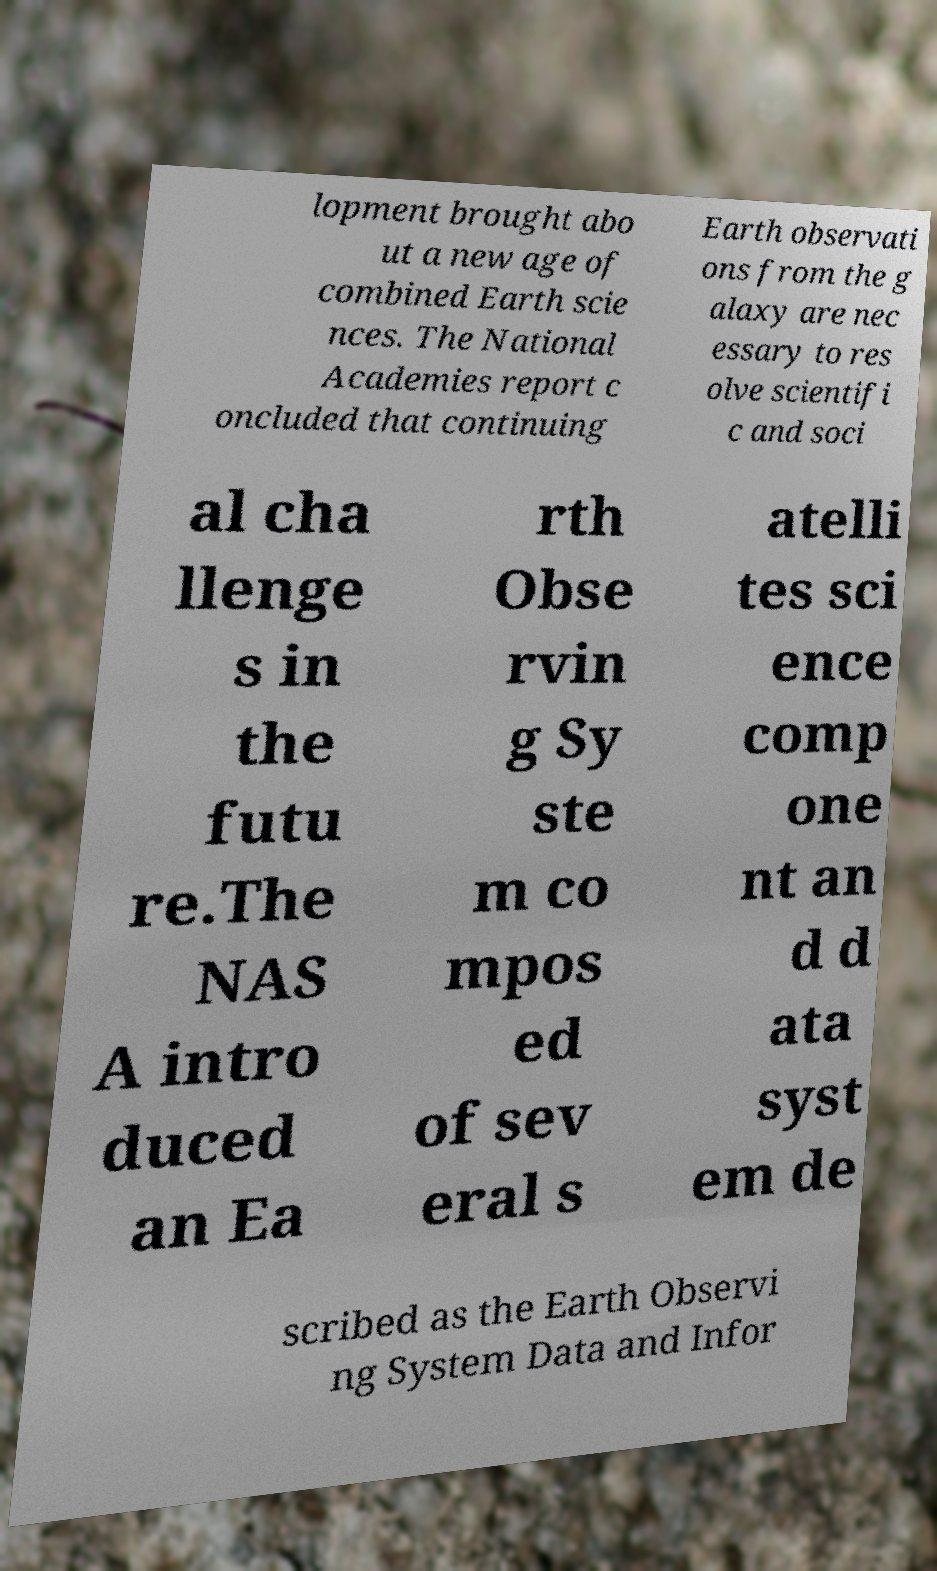Please read and relay the text visible in this image. What does it say? lopment brought abo ut a new age of combined Earth scie nces. The National Academies report c oncluded that continuing Earth observati ons from the g alaxy are nec essary to res olve scientifi c and soci al cha llenge s in the futu re.The NAS A intro duced an Ea rth Obse rvin g Sy ste m co mpos ed of sev eral s atelli tes sci ence comp one nt an d d ata syst em de scribed as the Earth Observi ng System Data and Infor 